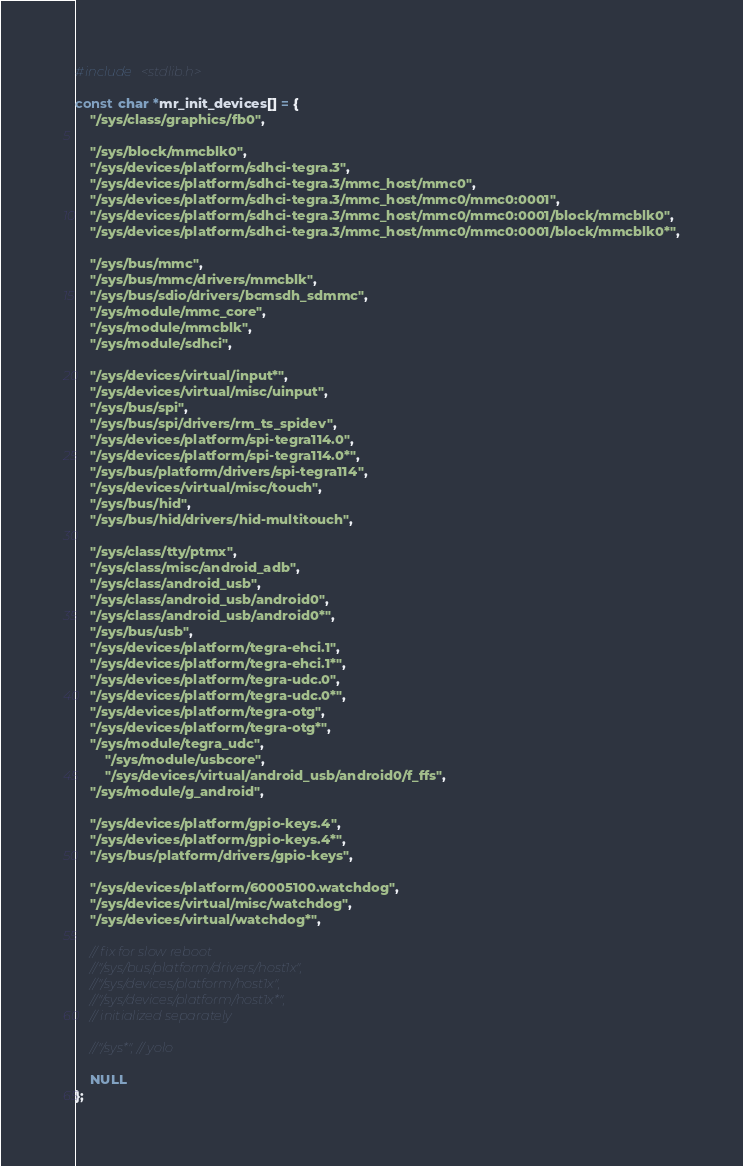Convert code to text. <code><loc_0><loc_0><loc_500><loc_500><_C_>#include <stdlib.h>

const char *mr_init_devices[] = {
	"/sys/class/graphics/fb0",

	"/sys/block/mmcblk0",
	"/sys/devices/platform/sdhci-tegra.3",
	"/sys/devices/platform/sdhci-tegra.3/mmc_host/mmc0",
	"/sys/devices/platform/sdhci-tegra.3/mmc_host/mmc0/mmc0:0001",
	"/sys/devices/platform/sdhci-tegra.3/mmc_host/mmc0/mmc0:0001/block/mmcblk0",
	"/sys/devices/platform/sdhci-tegra.3/mmc_host/mmc0/mmc0:0001/block/mmcblk0*",

	"/sys/bus/mmc",
	"/sys/bus/mmc/drivers/mmcblk",
	"/sys/bus/sdio/drivers/bcmsdh_sdmmc",
	"/sys/module/mmc_core",
	"/sys/module/mmcblk",
	"/sys/module/sdhci",

	"/sys/devices/virtual/input*",
	"/sys/devices/virtual/misc/uinput",
	"/sys/bus/spi",
	"/sys/bus/spi/drivers/rm_ts_spidev",
	"/sys/devices/platform/spi-tegra114.0",
	"/sys/devices/platform/spi-tegra114.0*",
	"/sys/bus/platform/drivers/spi-tegra114",
	"/sys/devices/virtual/misc/touch",
	"/sys/bus/hid",
	"/sys/bus/hid/drivers/hid-multitouch",

	"/sys/class/tty/ptmx",
	"/sys/class/misc/android_adb",
	"/sys/class/android_usb",
	"/sys/class/android_usb/android0",
	"/sys/class/android_usb/android0*",
	"/sys/bus/usb",
	"/sys/devices/platform/tegra-ehci.1",
	"/sys/devices/platform/tegra-ehci.1*",
	"/sys/devices/platform/tegra-udc.0",
	"/sys/devices/platform/tegra-udc.0*",
	"/sys/devices/platform/tegra-otg",
	"/sys/devices/platform/tegra-otg*",
	"/sys/module/tegra_udc",
        "/sys/module/usbcore",
        "/sys/devices/virtual/android_usb/android0/f_ffs",
	"/sys/module/g_android",

	"/sys/devices/platform/gpio-keys.4",
	"/sys/devices/platform/gpio-keys.4*",
	"/sys/bus/platform/drivers/gpio-keys",

	"/sys/devices/platform/60005100.watchdog",
	"/sys/devices/virtual/misc/watchdog",
	"/sys/devices/virtual/watchdog*",

	// fix for slow reboot
	//"/sys/bus/platform/drivers/host1x",
	//"/sys/devices/platform/host1x",
	//"/sys/devices/platform/host1x*",
	// initialized separately

	//"/sys*", // yolo

	NULL
};
</code> 